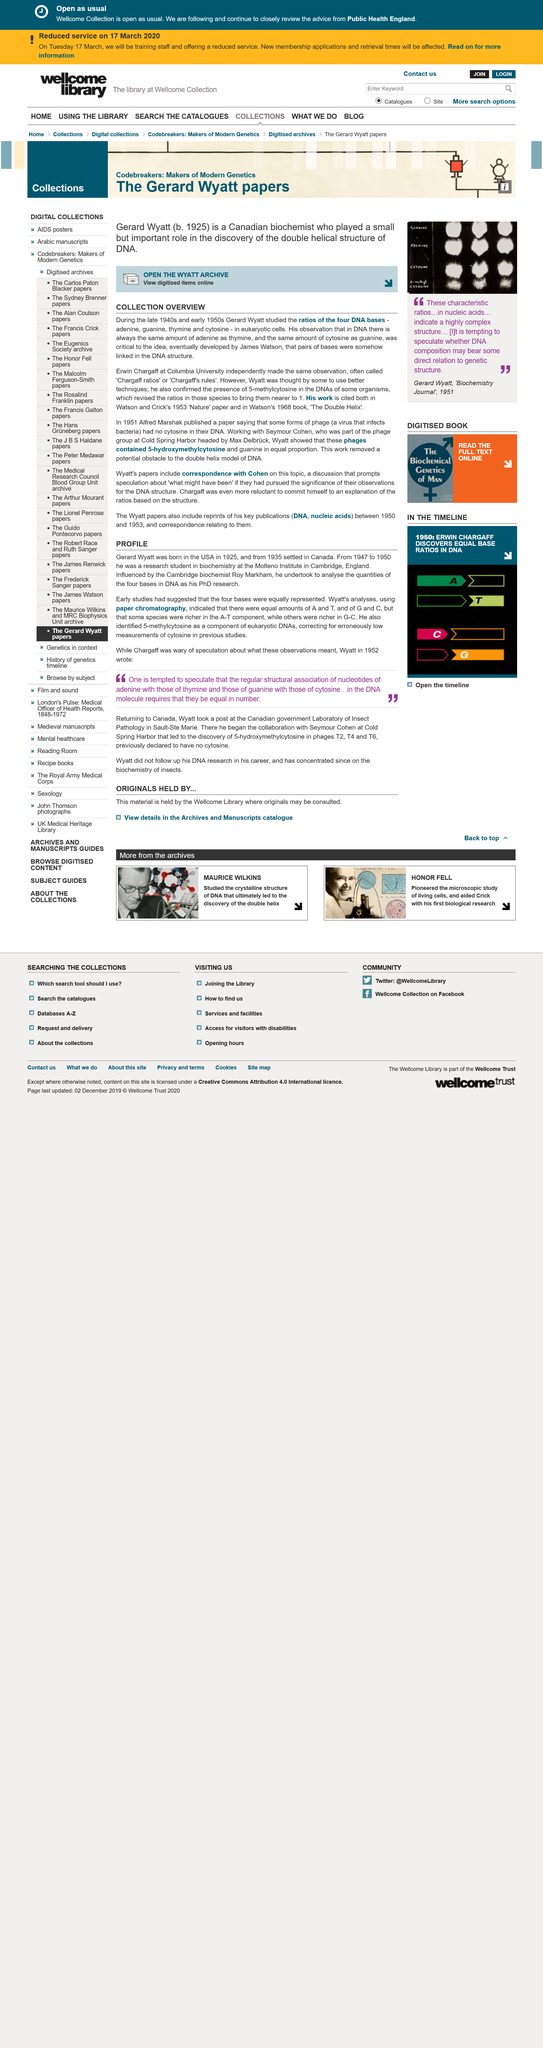Identify some key points in this picture. In his PhD research, Wyatt used paper chromatography, a type of chromatography. Gerard Wyatt was born in 1925. Erwin Chargaff's observation, which was called "Chargaff ratios" or "Chargaff's rules," was a series of observations made by Chargaff about the relative amounts of certain nucleotides in DNA. Chargaff's rules stated that the ratio of adenine to thymine in DNA was constant, and that the ratio of guanine to cytosine was also constant. These observations were a major contribution to the field of DNA research and are still commonly referenced today. Gerard Wyatt studied the ratios of the four DNA bases during the late 1940s and early 1950s. Gerard Wyatt observed that in DNA, there is always an equal amount of adenine and thymine, and an equal amount of cytosine and guanine. 